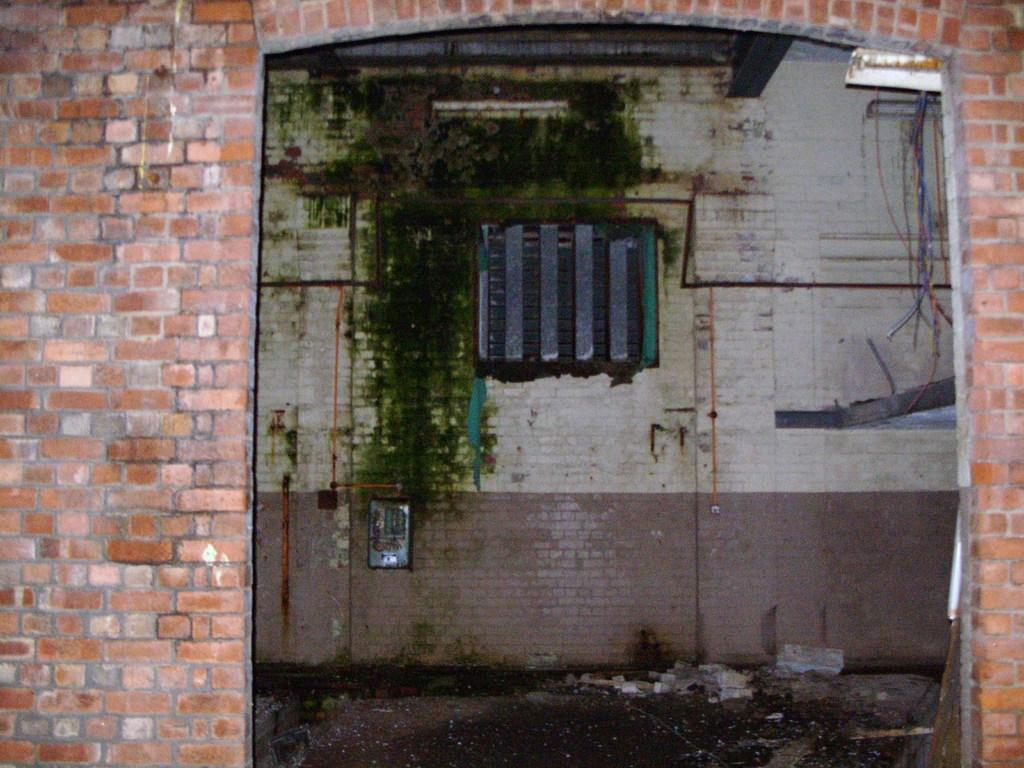What can be seen in the background of the image? There is a wall in the background of the image. What is located on the right side of the image? There are wires on the right side of the image. What type of material is visible at the bottom of the image? There are stones visible at the bottom of the image. What object is present in the image? There is a board present in the image. Can you tell me how many people are smiling in the image? There are no people present in the image, so it is not possible to determine how many people might be smiling. 